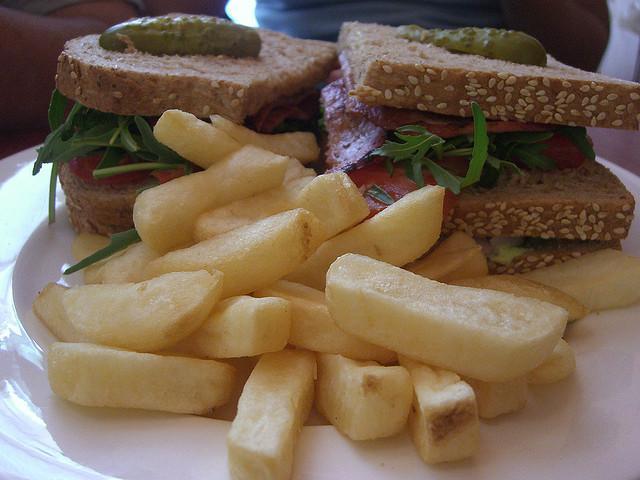How many sandwiches are visible?
Give a very brief answer. 2. 